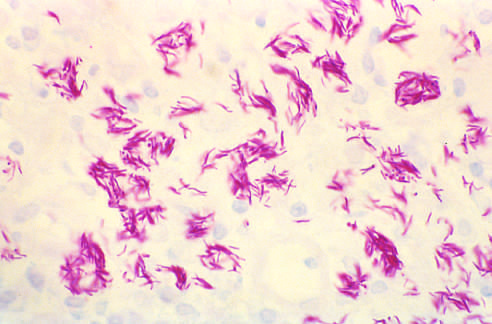does the greenish discoloration not occur in the absence of appropriate t-cell-mediated immunity?
Answer the question using a single word or phrase. No 